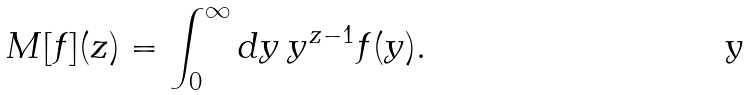Convert formula to latex. <formula><loc_0><loc_0><loc_500><loc_500>M [ f ] ( z ) = \int _ { 0 } ^ { \infty } d y \, y ^ { z - 1 } f ( y ) .</formula> 